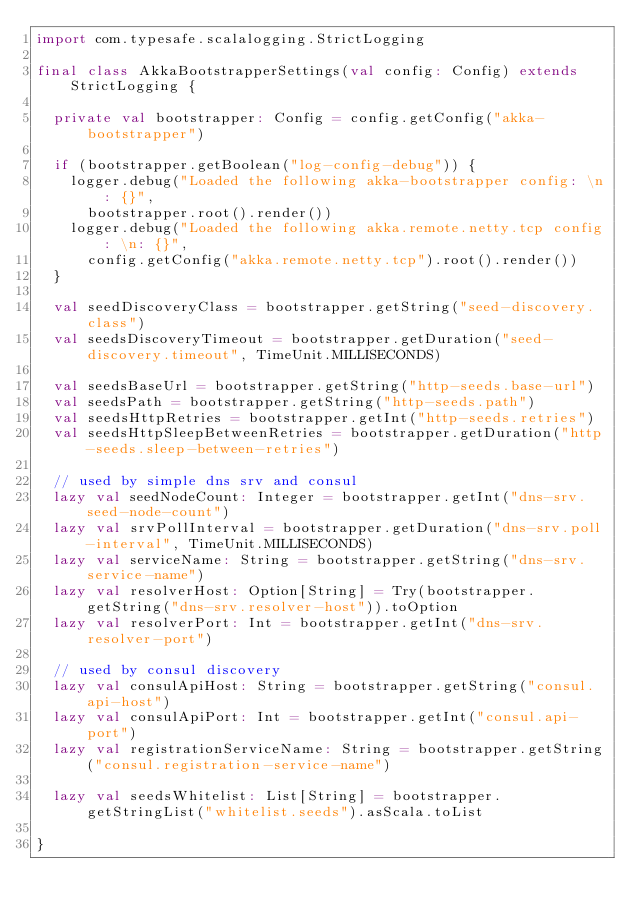Convert code to text. <code><loc_0><loc_0><loc_500><loc_500><_Scala_>import com.typesafe.scalalogging.StrictLogging

final class AkkaBootstrapperSettings(val config: Config) extends StrictLogging {

  private val bootstrapper: Config = config.getConfig("akka-bootstrapper")

  if (bootstrapper.getBoolean("log-config-debug")) {
    logger.debug("Loaded the following akka-bootstrapper config: \n: {}",
      bootstrapper.root().render())
    logger.debug("Loaded the following akka.remote.netty.tcp config: \n: {}",
      config.getConfig("akka.remote.netty.tcp").root().render())
  }

  val seedDiscoveryClass = bootstrapper.getString("seed-discovery.class")
  val seedsDiscoveryTimeout = bootstrapper.getDuration("seed-discovery.timeout", TimeUnit.MILLISECONDS)

  val seedsBaseUrl = bootstrapper.getString("http-seeds.base-url")
  val seedsPath = bootstrapper.getString("http-seeds.path")
  val seedsHttpRetries = bootstrapper.getInt("http-seeds.retries")
  val seedsHttpSleepBetweenRetries = bootstrapper.getDuration("http-seeds.sleep-between-retries")

  // used by simple dns srv and consul
  lazy val seedNodeCount: Integer = bootstrapper.getInt("dns-srv.seed-node-count")
  lazy val srvPollInterval = bootstrapper.getDuration("dns-srv.poll-interval", TimeUnit.MILLISECONDS)
  lazy val serviceName: String = bootstrapper.getString("dns-srv.service-name")
  lazy val resolverHost: Option[String] = Try(bootstrapper.getString("dns-srv.resolver-host")).toOption
  lazy val resolverPort: Int = bootstrapper.getInt("dns-srv.resolver-port")

  // used by consul discovery
  lazy val consulApiHost: String = bootstrapper.getString("consul.api-host")
  lazy val consulApiPort: Int = bootstrapper.getInt("consul.api-port")
  lazy val registrationServiceName: String = bootstrapper.getString("consul.registration-service-name")

  lazy val seedsWhitelist: List[String] = bootstrapper.getStringList("whitelist.seeds").asScala.toList

}
</code> 